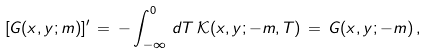Convert formula to latex. <formula><loc_0><loc_0><loc_500><loc_500>[ G ( x , y ; m ) ] ^ { \prime } \, = \, - \int _ { - \infty } ^ { 0 } \, d T \, { \mathcal { K } } ( x , y ; - m , T ) \, = \, G ( x , y ; - m ) \, ,</formula> 